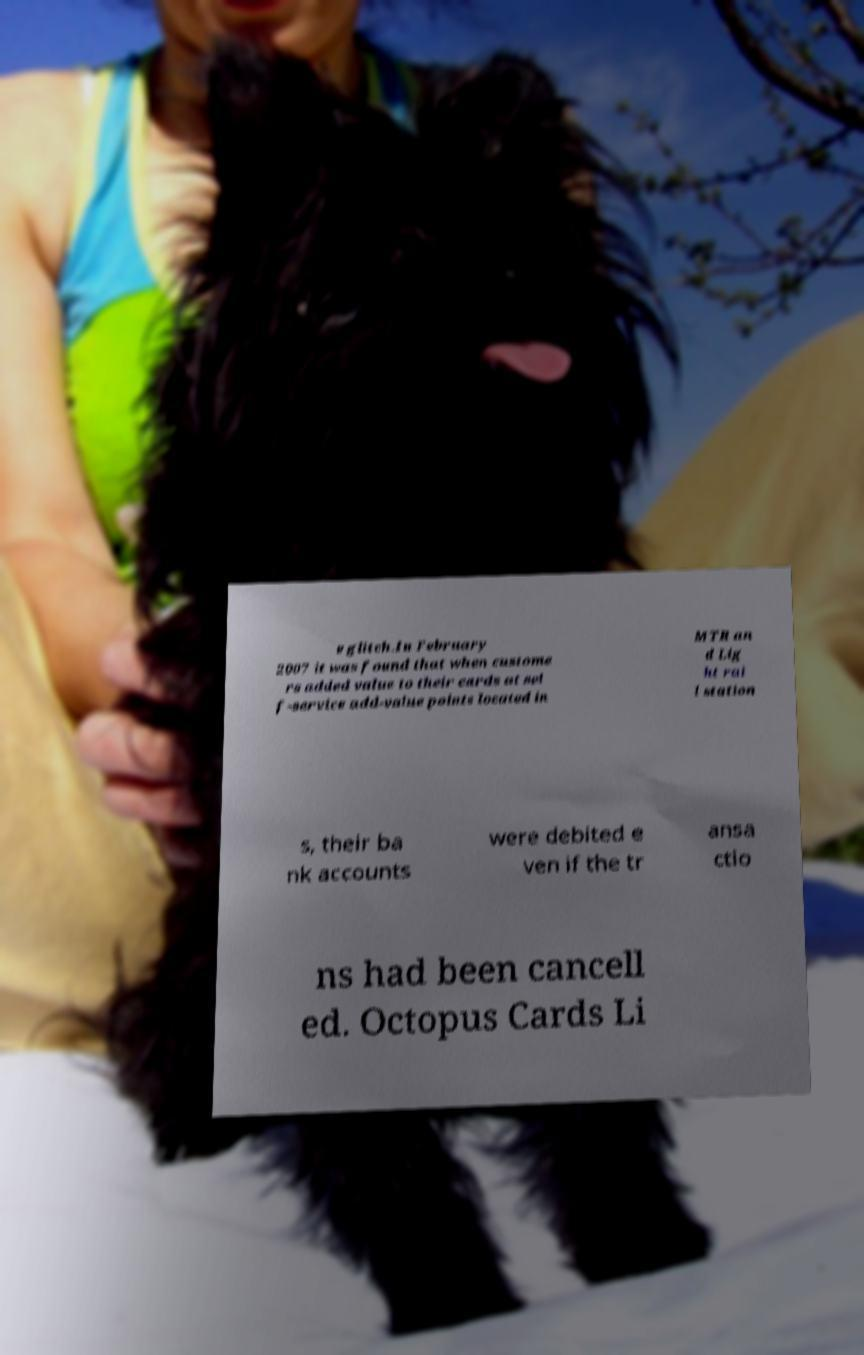Please read and relay the text visible in this image. What does it say? e glitch.In February 2007 it was found that when custome rs added value to their cards at sel f-service add-value points located in MTR an d Lig ht rai l station s, their ba nk accounts were debited e ven if the tr ansa ctio ns had been cancell ed. Octopus Cards Li 